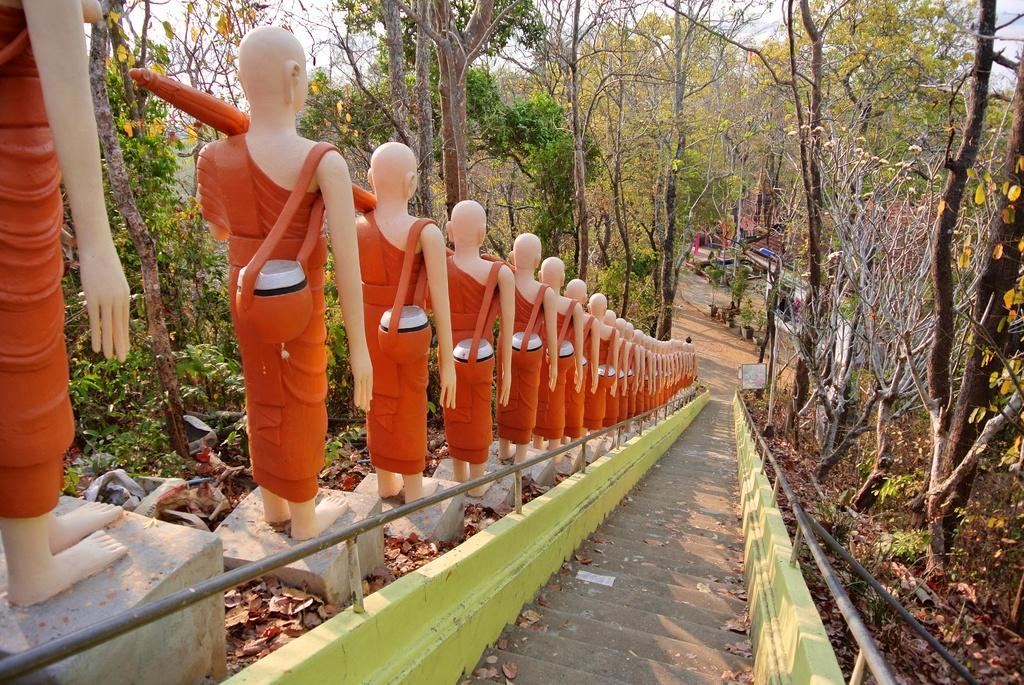What is located in the center of the image? There are statues and stairs in the center of the image. Can you describe the stairs in the image? Yes, there are stairs in the center and in the background of the image. What can be seen in the background of the image? There is a building, light, and the sky visible in the background. Where is the zebra located in the image? There is no zebra present in the image. What type of toy can be seen in the alley in the image? There is no alley or toy present in the image. 